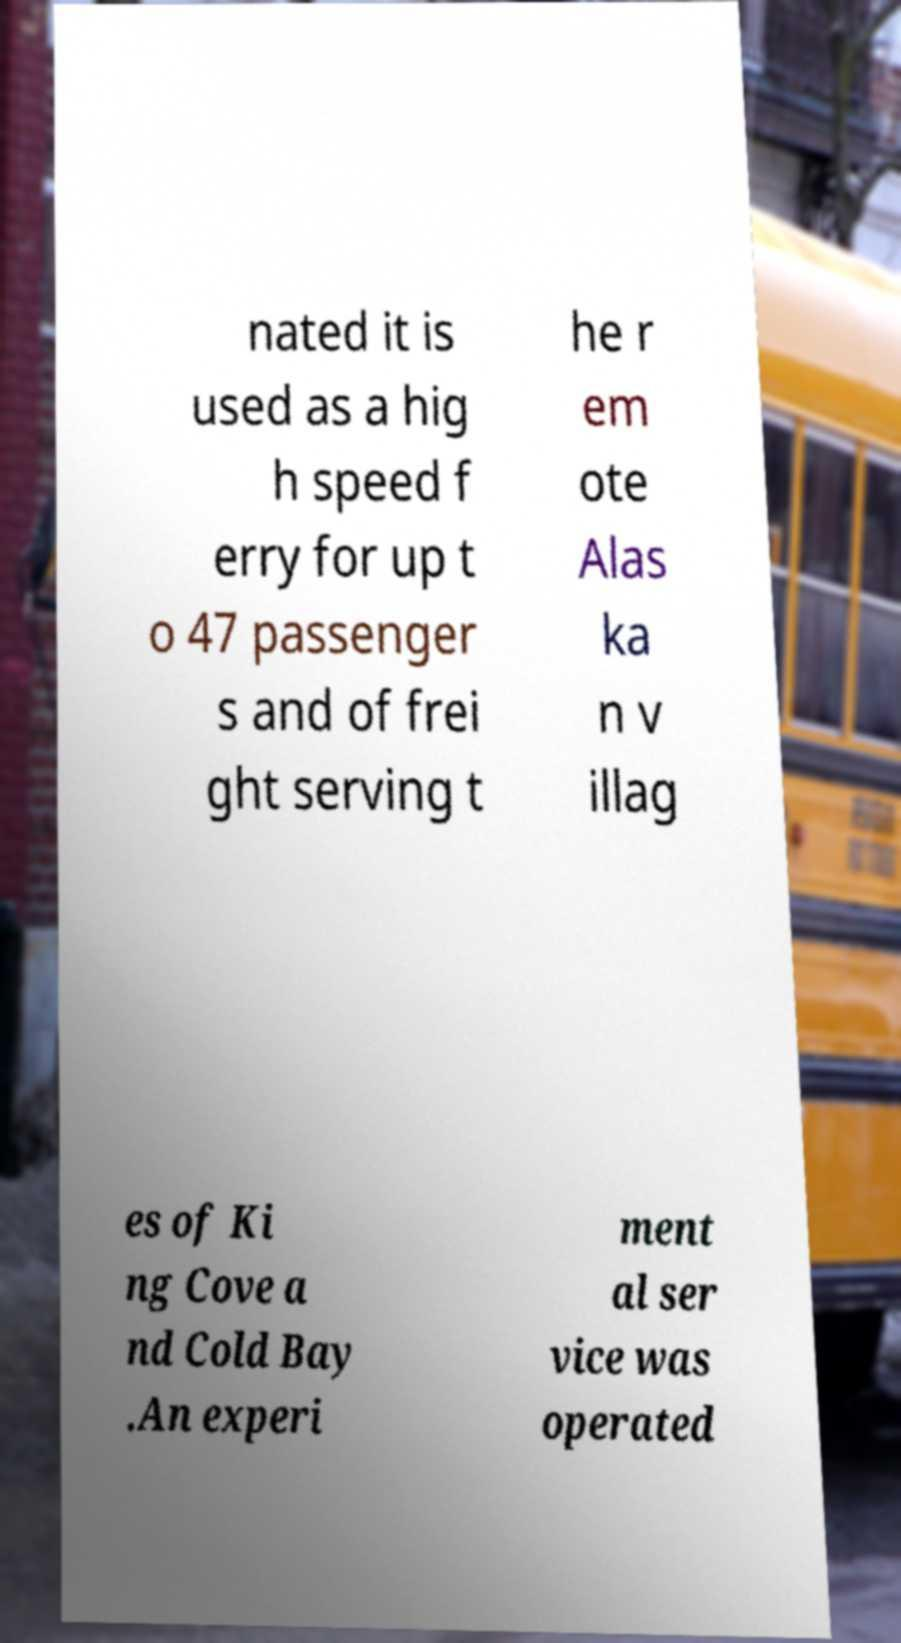I need the written content from this picture converted into text. Can you do that? nated it is used as a hig h speed f erry for up t o 47 passenger s and of frei ght serving t he r em ote Alas ka n v illag es of Ki ng Cove a nd Cold Bay .An experi ment al ser vice was operated 